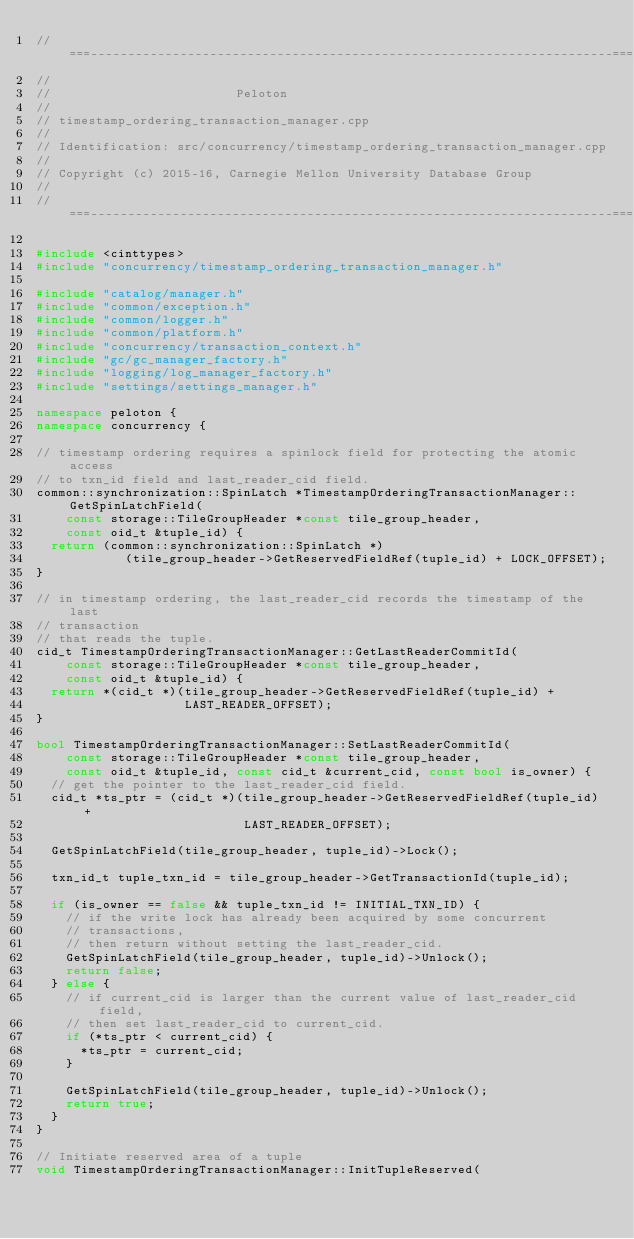<code> <loc_0><loc_0><loc_500><loc_500><_C++_>//===----------------------------------------------------------------------===//
//
//                         Peloton
//
// timestamp_ordering_transaction_manager.cpp
//
// Identification: src/concurrency/timestamp_ordering_transaction_manager.cpp
//
// Copyright (c) 2015-16, Carnegie Mellon University Database Group
//
//===----------------------------------------------------------------------===//

#include <cinttypes>
#include "concurrency/timestamp_ordering_transaction_manager.h"

#include "catalog/manager.h"
#include "common/exception.h"
#include "common/logger.h"
#include "common/platform.h"
#include "concurrency/transaction_context.h"
#include "gc/gc_manager_factory.h"
#include "logging/log_manager_factory.h"
#include "settings/settings_manager.h"

namespace peloton {
namespace concurrency {

// timestamp ordering requires a spinlock field for protecting the atomic access
// to txn_id field and last_reader_cid field.
common::synchronization::SpinLatch *TimestampOrderingTransactionManager::GetSpinLatchField(
    const storage::TileGroupHeader *const tile_group_header,
    const oid_t &tuple_id) {
  return (common::synchronization::SpinLatch *)
            (tile_group_header->GetReservedFieldRef(tuple_id) + LOCK_OFFSET);
}

// in timestamp ordering, the last_reader_cid records the timestamp of the last
// transaction
// that reads the tuple.
cid_t TimestampOrderingTransactionManager::GetLastReaderCommitId(
    const storage::TileGroupHeader *const tile_group_header,
    const oid_t &tuple_id) {
  return *(cid_t *)(tile_group_header->GetReservedFieldRef(tuple_id) +
                    LAST_READER_OFFSET);
}

bool TimestampOrderingTransactionManager::SetLastReaderCommitId(
    const storage::TileGroupHeader *const tile_group_header,
    const oid_t &tuple_id, const cid_t &current_cid, const bool is_owner) {
  // get the pointer to the last_reader_cid field.
  cid_t *ts_ptr = (cid_t *)(tile_group_header->GetReservedFieldRef(tuple_id) +
                            LAST_READER_OFFSET);

  GetSpinLatchField(tile_group_header, tuple_id)->Lock();

  txn_id_t tuple_txn_id = tile_group_header->GetTransactionId(tuple_id);

  if (is_owner == false && tuple_txn_id != INITIAL_TXN_ID) {
    // if the write lock has already been acquired by some concurrent
    // transactions,
    // then return without setting the last_reader_cid.
    GetSpinLatchField(tile_group_header, tuple_id)->Unlock();
    return false;
  } else {
    // if current_cid is larger than the current value of last_reader_cid field,
    // then set last_reader_cid to current_cid.
    if (*ts_ptr < current_cid) {
      *ts_ptr = current_cid;
    }

    GetSpinLatchField(tile_group_header, tuple_id)->Unlock();
    return true;
  }
}

// Initiate reserved area of a tuple
void TimestampOrderingTransactionManager::InitTupleReserved(</code> 